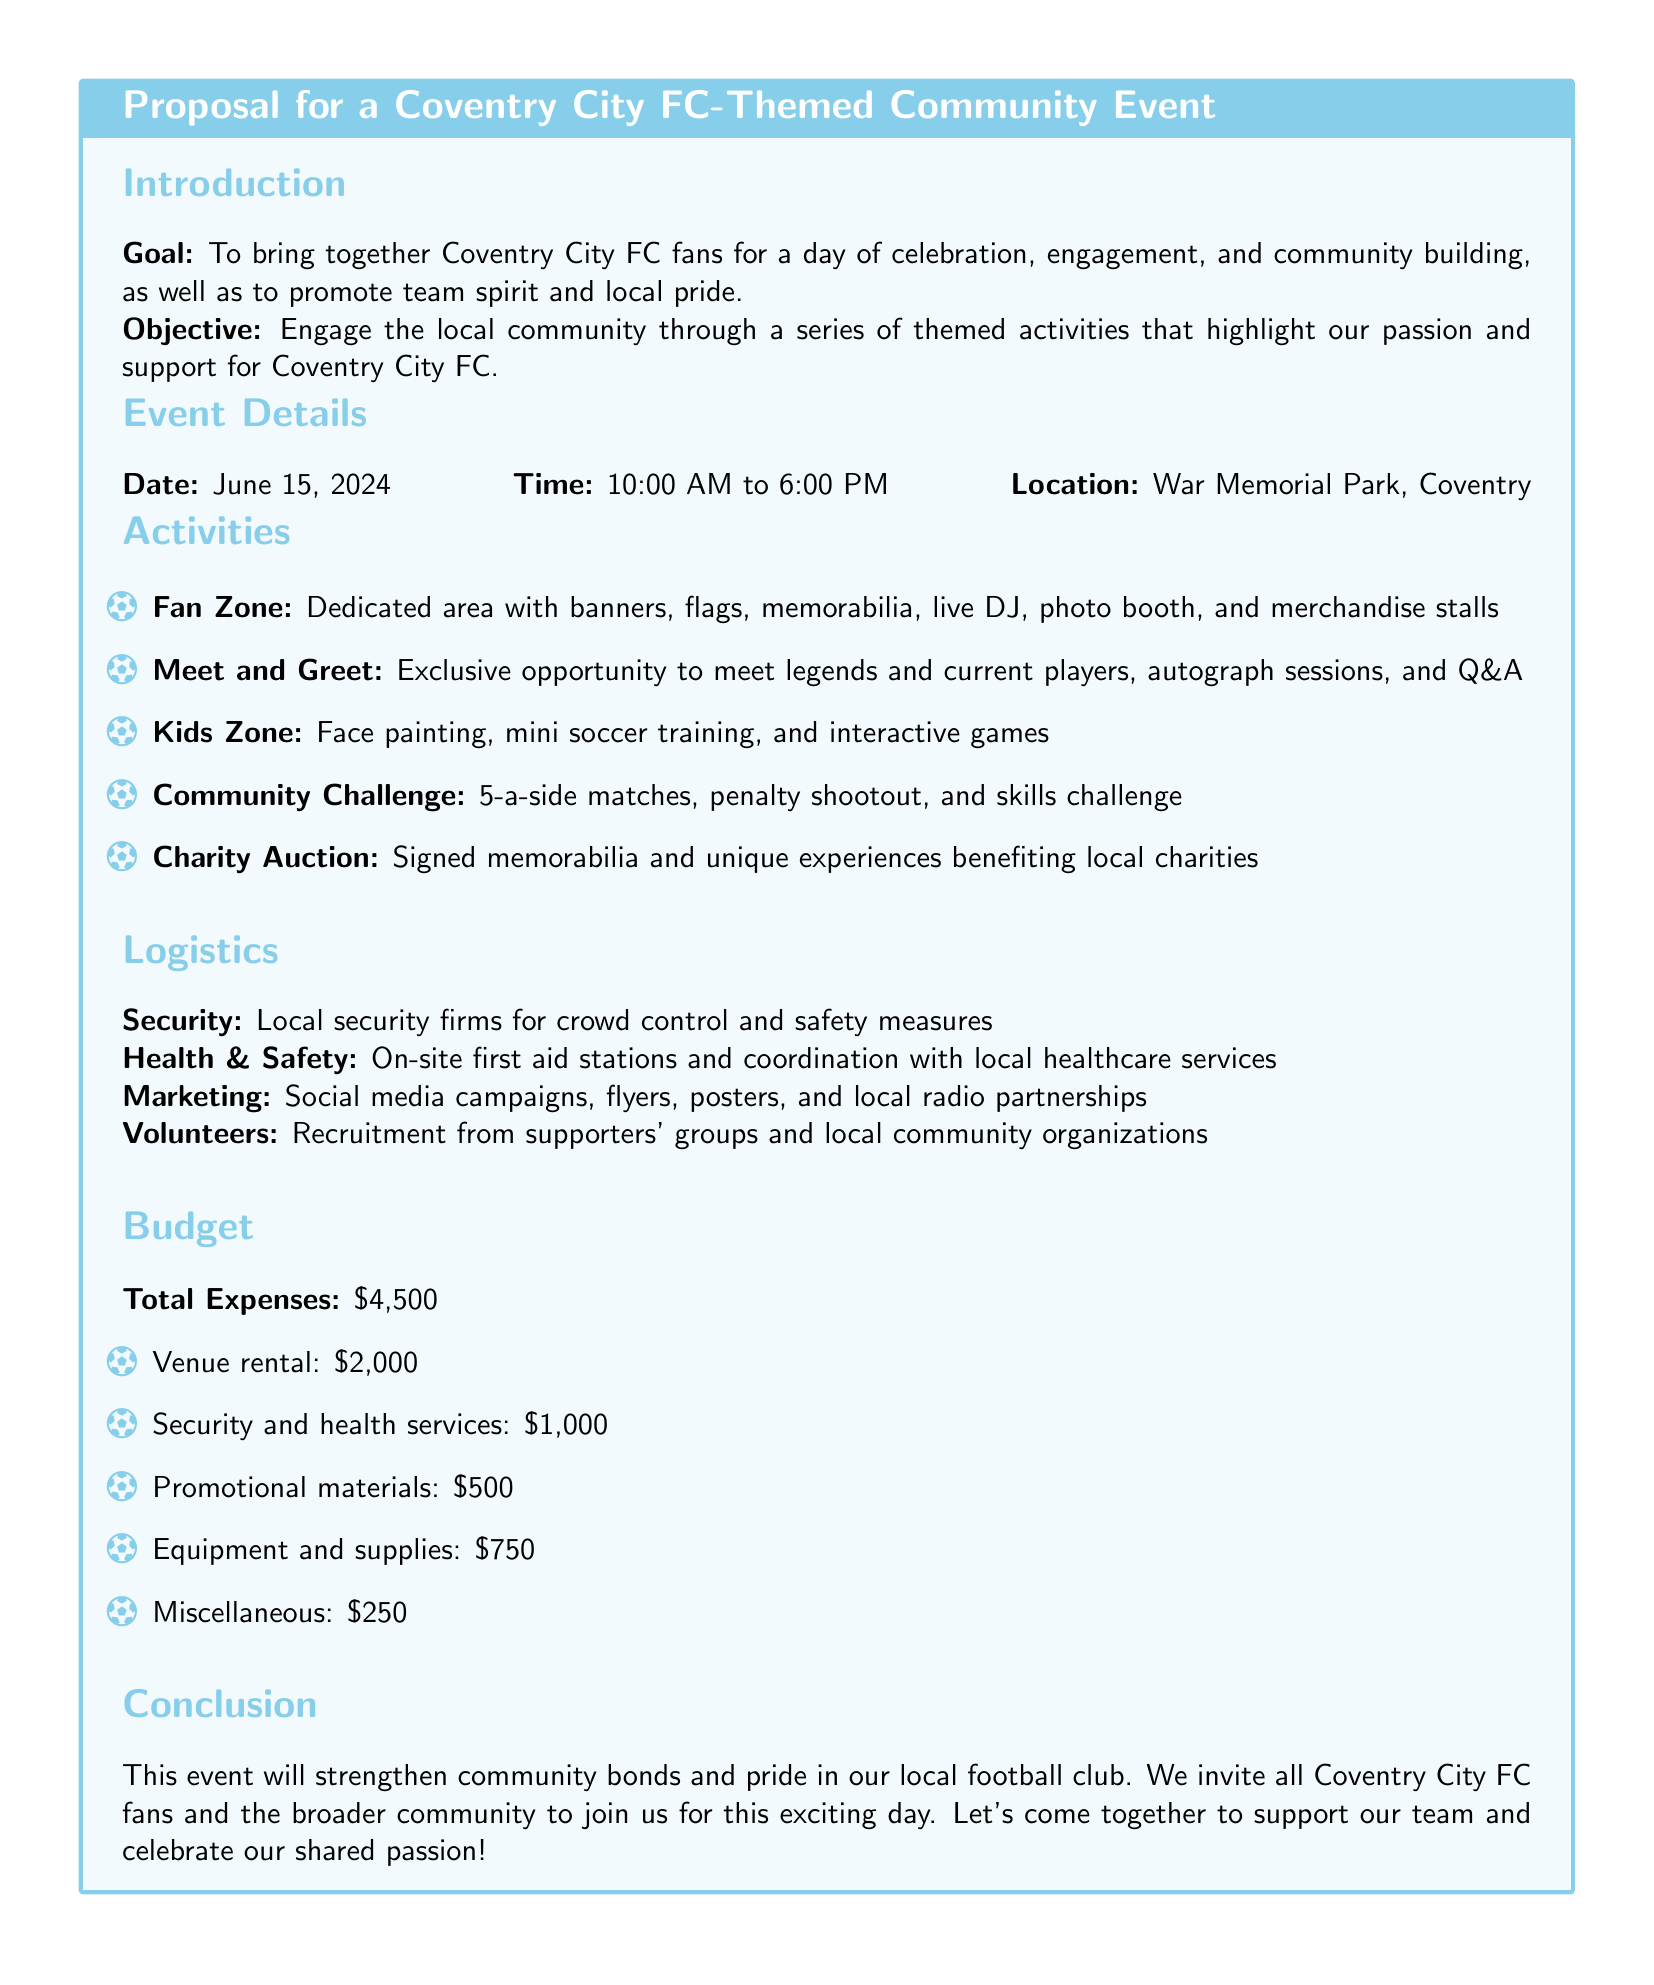What is the goal of the event? The goal is to bring together Coventry City FC fans for a day of celebration, engagement, and community building.
Answer: To bring together Coventry City FC fans for a day of celebration, engagement, and community building When is the event scheduled? The date of the event is mentioned in the event details section.
Answer: June 15, 2024 What time does the event start? The start time is specified in the event details section of the document.
Answer: 10:00 AM Where will the event take place? The location is clearly stated in the event details section.
Answer: War Memorial Park, Coventry What activity includes legends and current players? The document specifies a meet and greet session that features legends and current players.
Answer: Meet and Greet What is the total budget for the event? The total expenses for organizing the event are stated in the budget section.
Answer: \$4,500 How much is allocated for venue rental? The budget section lists the allocations for each expense, including venue rental.
Answer: \$2,000 What type of auction is mentioned? The type of auction that will benefit local charities is specified in the activities section.
Answer: Charity Auction Which activity allows kids to participate? The document highlights a specific zone dedicated to children and their activities.
Answer: Kids Zone 